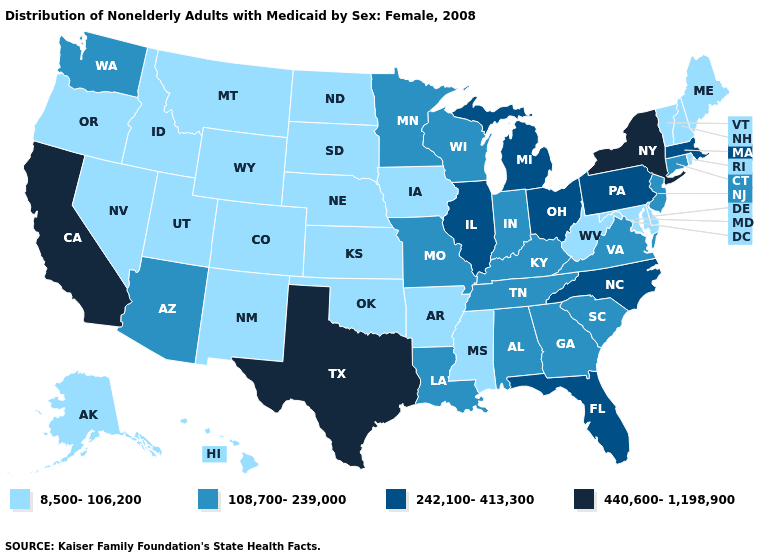Is the legend a continuous bar?
Quick response, please. No. Among the states that border Rhode Island , which have the lowest value?
Write a very short answer. Connecticut. Does the first symbol in the legend represent the smallest category?
Be succinct. Yes. Does Missouri have a higher value than Mississippi?
Quick response, please. Yes. How many symbols are there in the legend?
Be succinct. 4. Among the states that border Indiana , which have the lowest value?
Concise answer only. Kentucky. Among the states that border Illinois , which have the highest value?
Keep it brief. Indiana, Kentucky, Missouri, Wisconsin. Does Kentucky have the highest value in the South?
Quick response, please. No. Name the states that have a value in the range 8,500-106,200?
Keep it brief. Alaska, Arkansas, Colorado, Delaware, Hawaii, Idaho, Iowa, Kansas, Maine, Maryland, Mississippi, Montana, Nebraska, Nevada, New Hampshire, New Mexico, North Dakota, Oklahoma, Oregon, Rhode Island, South Dakota, Utah, Vermont, West Virginia, Wyoming. What is the value of South Dakota?
Concise answer only. 8,500-106,200. Among the states that border Illinois , which have the lowest value?
Quick response, please. Iowa. What is the value of Wisconsin?
Give a very brief answer. 108,700-239,000. What is the highest value in states that border Nevada?
Short answer required. 440,600-1,198,900. Does the map have missing data?
Short answer required. No. Name the states that have a value in the range 108,700-239,000?
Keep it brief. Alabama, Arizona, Connecticut, Georgia, Indiana, Kentucky, Louisiana, Minnesota, Missouri, New Jersey, South Carolina, Tennessee, Virginia, Washington, Wisconsin. 